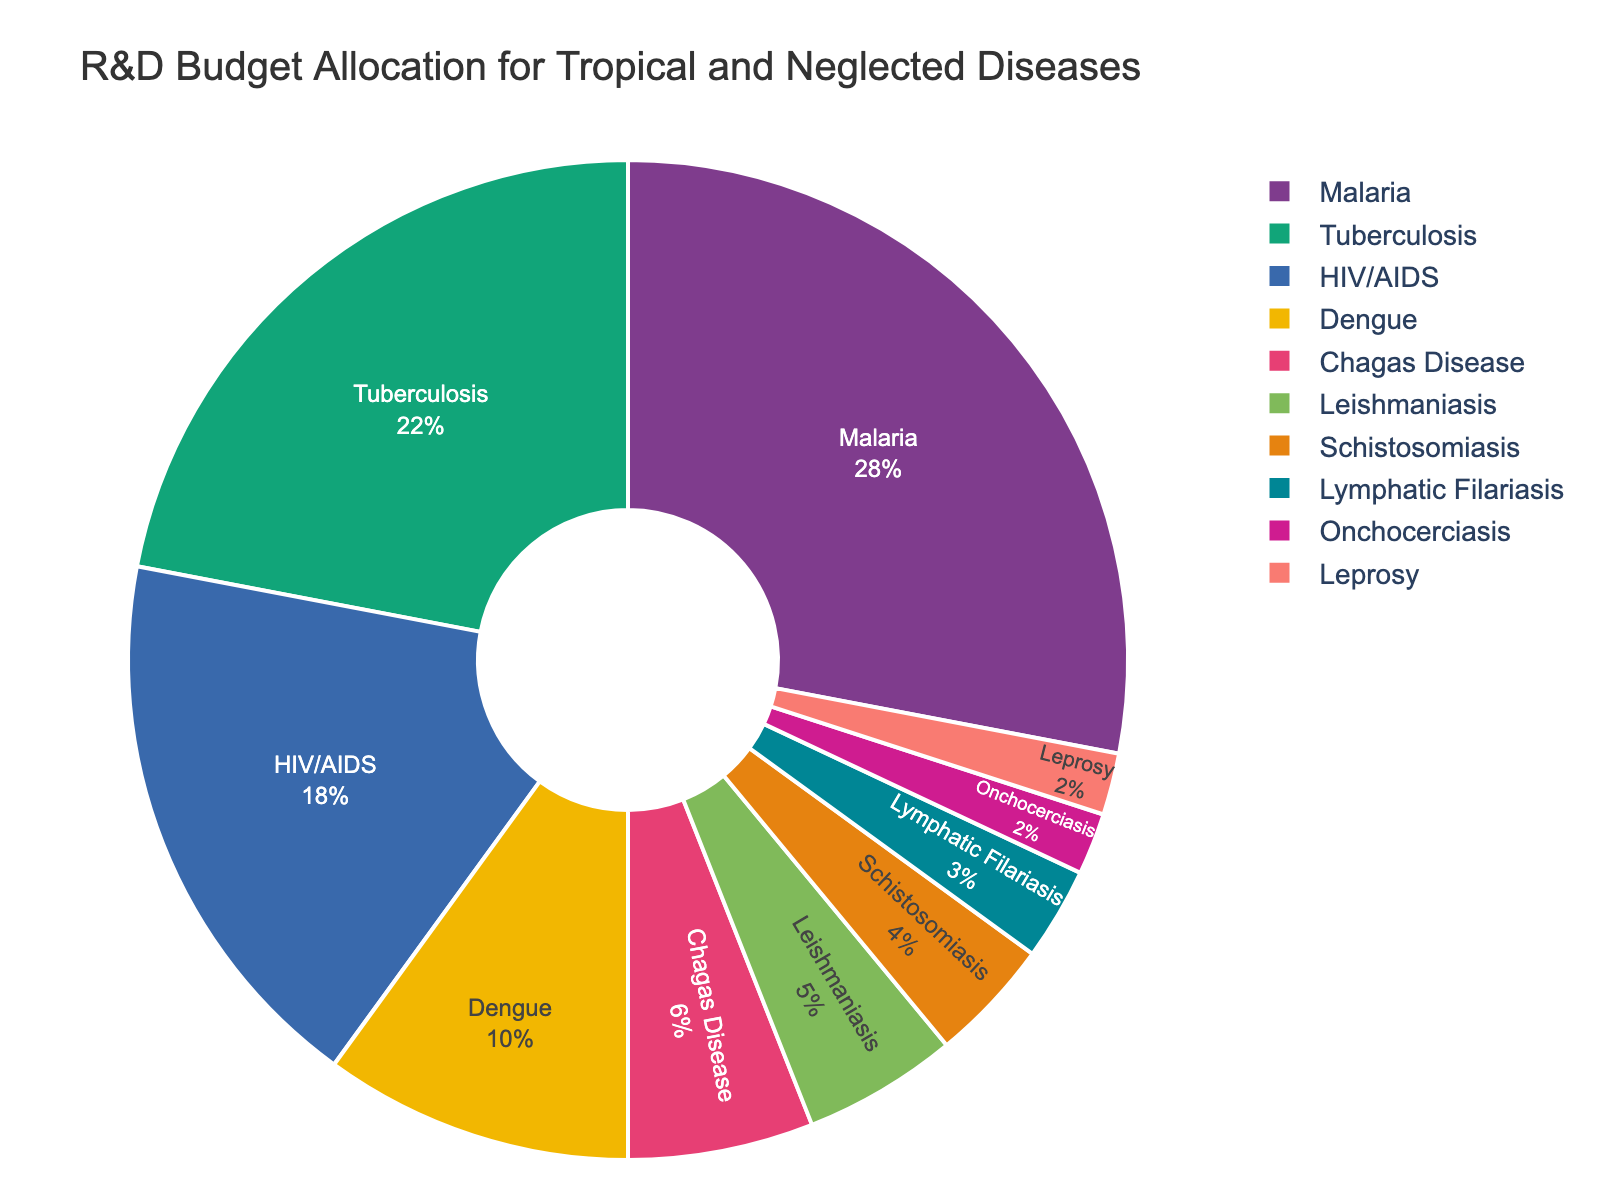What's the total budget allocation for Malaria and Tuberculosis? To find the total budget allocation for Malaria and Tuberculosis, you sum their respective budget allocation percentages: Malaria (28%) + Tuberculosis (22%) = 50%
Answer: 50% Which disease has the lowest budget allocation? To determine which disease has the lowest budget allocation, you look for the smallest percentage in the pie chart. Leprosy and Onchocerciasis both have the lowest budget allocation at 2% each
Answer: Leprosy and Onchocerciasis Is the budget allocation for Malaria greater than the combined budget allocation for Leishmaniasis and Schistosomiasis? First, find the combined budget allocation for Leishmaniasis (5%) and Schistosomiasis (4%), which equals 9%. Then, compare this combined allocation with Malaria's allocation (28%). Since 28% > 9%, the allocation for Malaria is indeed greater
Answer: Yes What's the difference in budget allocation between HIV/AIDS and Dengue? To find the difference in budget allocation between HIV/AIDS and Dengue, subtract Dengue's allocation (10%) from HIV/AIDS's allocation (18%): 18% - 10% = 8%
Answer: 8% Which diseases have a budget allocation of less than 5%? Look at the sections of the pie chart with percentages less than 5%: Schistosomiasis (4%), Lymphatic Filariasis (3%), Onchocerciasis (2%), and Leprosy (2%)
Answer: Schistosomiasis, Lymphatic Filariasis, Onchocerciasis, Leprosy Combine the budget allocations for Dengue, Chagas Disease, and Leishmaniasis. What's the total? To find the total, sum the allocated percentages for Dengue (10%), Chagas Disease (6%), and Leishmaniasis (5%): 10% + 6% + 5% = 21%
Answer: 21% Is the budget allocation for Malaria double that of HIV/AIDS? Compare Malaria's budget allocation (28%) with double the allocation for HIV/AIDS, which would be 18% * 2 = 36%. Since 28% is less than 36%, Malaria's budget is not double that of HIV/AIDS
Answer: No Which three diseases have the highest budget allocations, and what is their combined share? Identify the top three budget allocations: Malaria (28%), Tuberculosis (22%), and HIV/AIDS (18%). Sum these percentages: 28% + 22% + 18% = 68%
Answer: Malaria, Tuberculosis, HIV/AIDS; 68% What percentage of the budget allocation is shared among the diseases other than Malaria, Tuberculosis, and HIV/AIDS? Sum the percentages of the three largest allocations: Malaria (28%), Tuberculosis (22%), HIV/AIDS (18%) to get 68%. Subtract this sum from 100%: 100% - 68% = 32%
Answer: 32% 